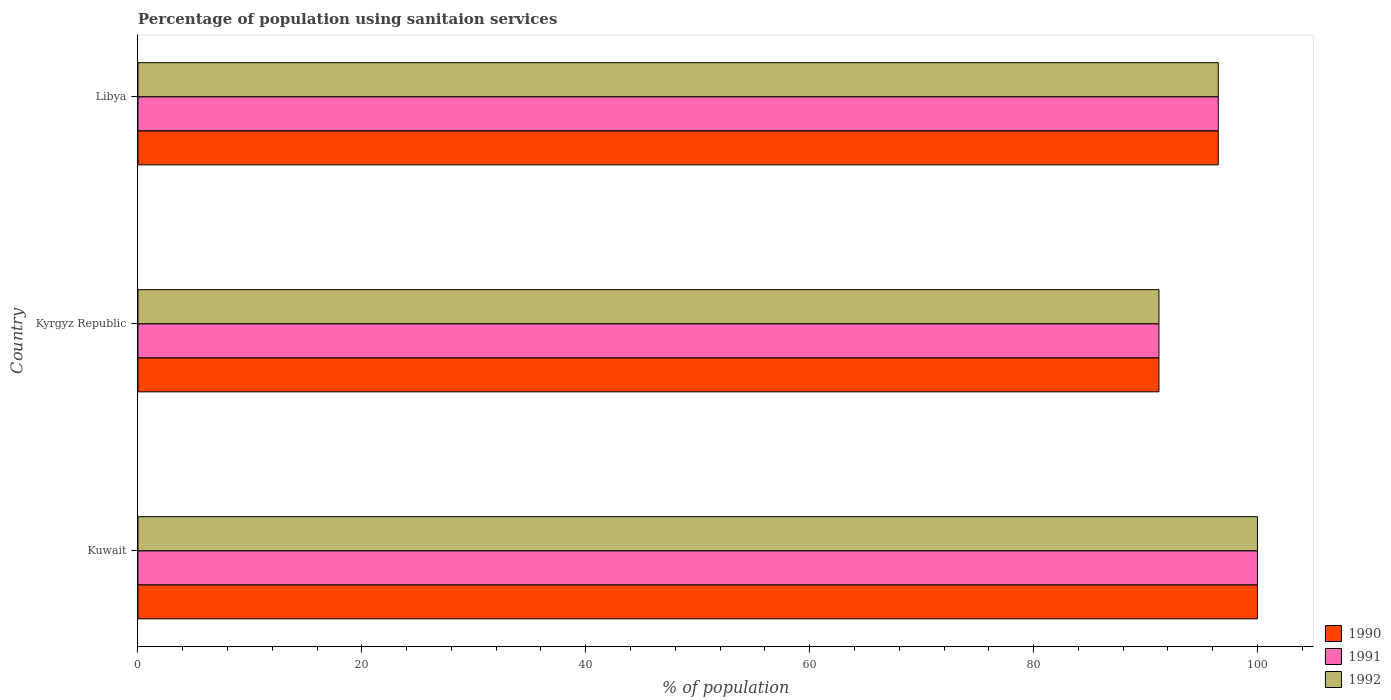How many different coloured bars are there?
Give a very brief answer. 3. Are the number of bars on each tick of the Y-axis equal?
Give a very brief answer. Yes. How many bars are there on the 3rd tick from the top?
Keep it short and to the point. 3. What is the label of the 1st group of bars from the top?
Provide a short and direct response. Libya. In how many cases, is the number of bars for a given country not equal to the number of legend labels?
Your answer should be compact. 0. What is the percentage of population using sanitaion services in 1991 in Kuwait?
Your answer should be very brief. 100. Across all countries, what is the maximum percentage of population using sanitaion services in 1992?
Keep it short and to the point. 100. Across all countries, what is the minimum percentage of population using sanitaion services in 1990?
Provide a short and direct response. 91.2. In which country was the percentage of population using sanitaion services in 1991 maximum?
Your answer should be very brief. Kuwait. In which country was the percentage of population using sanitaion services in 1991 minimum?
Your answer should be very brief. Kyrgyz Republic. What is the total percentage of population using sanitaion services in 1991 in the graph?
Your response must be concise. 287.7. What is the difference between the percentage of population using sanitaion services in 1992 in Kyrgyz Republic and the percentage of population using sanitaion services in 1990 in Libya?
Keep it short and to the point. -5.3. What is the average percentage of population using sanitaion services in 1991 per country?
Offer a terse response. 95.9. What is the difference between the percentage of population using sanitaion services in 1990 and percentage of population using sanitaion services in 1992 in Kyrgyz Republic?
Offer a very short reply. 0. In how many countries, is the percentage of population using sanitaion services in 1992 greater than 60 %?
Make the answer very short. 3. What is the ratio of the percentage of population using sanitaion services in 1991 in Kyrgyz Republic to that in Libya?
Offer a very short reply. 0.95. Is the difference between the percentage of population using sanitaion services in 1990 in Kuwait and Libya greater than the difference between the percentage of population using sanitaion services in 1992 in Kuwait and Libya?
Your answer should be very brief. No. What is the difference between the highest and the second highest percentage of population using sanitaion services in 1991?
Provide a succinct answer. 3.5. What is the difference between the highest and the lowest percentage of population using sanitaion services in 1991?
Offer a terse response. 8.8. Is the sum of the percentage of population using sanitaion services in 1990 in Kuwait and Kyrgyz Republic greater than the maximum percentage of population using sanitaion services in 1992 across all countries?
Give a very brief answer. Yes. What does the 1st bar from the top in Kuwait represents?
Provide a short and direct response. 1992. Is it the case that in every country, the sum of the percentage of population using sanitaion services in 1991 and percentage of population using sanitaion services in 1990 is greater than the percentage of population using sanitaion services in 1992?
Your answer should be compact. Yes. How many bars are there?
Your answer should be compact. 9. Are the values on the major ticks of X-axis written in scientific E-notation?
Offer a very short reply. No. Does the graph contain grids?
Your answer should be compact. No. Where does the legend appear in the graph?
Keep it short and to the point. Bottom right. How many legend labels are there?
Your answer should be very brief. 3. How are the legend labels stacked?
Your response must be concise. Vertical. What is the title of the graph?
Give a very brief answer. Percentage of population using sanitaion services. Does "1993" appear as one of the legend labels in the graph?
Provide a short and direct response. No. What is the label or title of the X-axis?
Provide a succinct answer. % of population. What is the % of population in 1990 in Kuwait?
Your answer should be very brief. 100. What is the % of population in 1991 in Kuwait?
Your response must be concise. 100. What is the % of population in 1992 in Kuwait?
Make the answer very short. 100. What is the % of population in 1990 in Kyrgyz Republic?
Offer a very short reply. 91.2. What is the % of population in 1991 in Kyrgyz Republic?
Give a very brief answer. 91.2. What is the % of population in 1992 in Kyrgyz Republic?
Offer a very short reply. 91.2. What is the % of population in 1990 in Libya?
Your response must be concise. 96.5. What is the % of population in 1991 in Libya?
Your answer should be compact. 96.5. What is the % of population of 1992 in Libya?
Provide a short and direct response. 96.5. Across all countries, what is the maximum % of population of 1990?
Provide a short and direct response. 100. Across all countries, what is the maximum % of population of 1992?
Provide a short and direct response. 100. Across all countries, what is the minimum % of population in 1990?
Offer a terse response. 91.2. Across all countries, what is the minimum % of population in 1991?
Your response must be concise. 91.2. Across all countries, what is the minimum % of population in 1992?
Make the answer very short. 91.2. What is the total % of population in 1990 in the graph?
Provide a succinct answer. 287.7. What is the total % of population in 1991 in the graph?
Keep it short and to the point. 287.7. What is the total % of population in 1992 in the graph?
Your answer should be compact. 287.7. What is the difference between the % of population of 1990 in Kuwait and that in Kyrgyz Republic?
Provide a short and direct response. 8.8. What is the difference between the % of population of 1991 in Kuwait and that in Kyrgyz Republic?
Your answer should be compact. 8.8. What is the difference between the % of population of 1992 in Kuwait and that in Kyrgyz Republic?
Offer a terse response. 8.8. What is the difference between the % of population in 1990 in Kuwait and that in Libya?
Keep it short and to the point. 3.5. What is the difference between the % of population of 1991 in Kuwait and that in Libya?
Give a very brief answer. 3.5. What is the difference between the % of population in 1992 in Kuwait and that in Libya?
Make the answer very short. 3.5. What is the difference between the % of population of 1992 in Kyrgyz Republic and that in Libya?
Provide a succinct answer. -5.3. What is the difference between the % of population in 1990 in Kuwait and the % of population in 1992 in Libya?
Make the answer very short. 3.5. What is the difference between the % of population of 1991 in Kuwait and the % of population of 1992 in Libya?
Your answer should be compact. 3.5. What is the difference between the % of population of 1990 in Kyrgyz Republic and the % of population of 1992 in Libya?
Provide a succinct answer. -5.3. What is the difference between the % of population in 1991 in Kyrgyz Republic and the % of population in 1992 in Libya?
Offer a terse response. -5.3. What is the average % of population in 1990 per country?
Ensure brevity in your answer.  95.9. What is the average % of population of 1991 per country?
Give a very brief answer. 95.9. What is the average % of population of 1992 per country?
Your response must be concise. 95.9. What is the difference between the % of population of 1991 and % of population of 1992 in Kyrgyz Republic?
Offer a very short reply. 0. What is the difference between the % of population in 1991 and % of population in 1992 in Libya?
Your response must be concise. 0. What is the ratio of the % of population of 1990 in Kuwait to that in Kyrgyz Republic?
Provide a short and direct response. 1.1. What is the ratio of the % of population of 1991 in Kuwait to that in Kyrgyz Republic?
Your answer should be compact. 1.1. What is the ratio of the % of population of 1992 in Kuwait to that in Kyrgyz Republic?
Your answer should be very brief. 1.1. What is the ratio of the % of population of 1990 in Kuwait to that in Libya?
Provide a short and direct response. 1.04. What is the ratio of the % of population in 1991 in Kuwait to that in Libya?
Your response must be concise. 1.04. What is the ratio of the % of population in 1992 in Kuwait to that in Libya?
Your answer should be very brief. 1.04. What is the ratio of the % of population of 1990 in Kyrgyz Republic to that in Libya?
Your response must be concise. 0.95. What is the ratio of the % of population of 1991 in Kyrgyz Republic to that in Libya?
Keep it short and to the point. 0.95. What is the ratio of the % of population in 1992 in Kyrgyz Republic to that in Libya?
Provide a succinct answer. 0.95. What is the difference between the highest and the second highest % of population in 1991?
Ensure brevity in your answer.  3.5. What is the difference between the highest and the second highest % of population of 1992?
Offer a terse response. 3.5. What is the difference between the highest and the lowest % of population of 1990?
Provide a succinct answer. 8.8. What is the difference between the highest and the lowest % of population in 1991?
Make the answer very short. 8.8. 